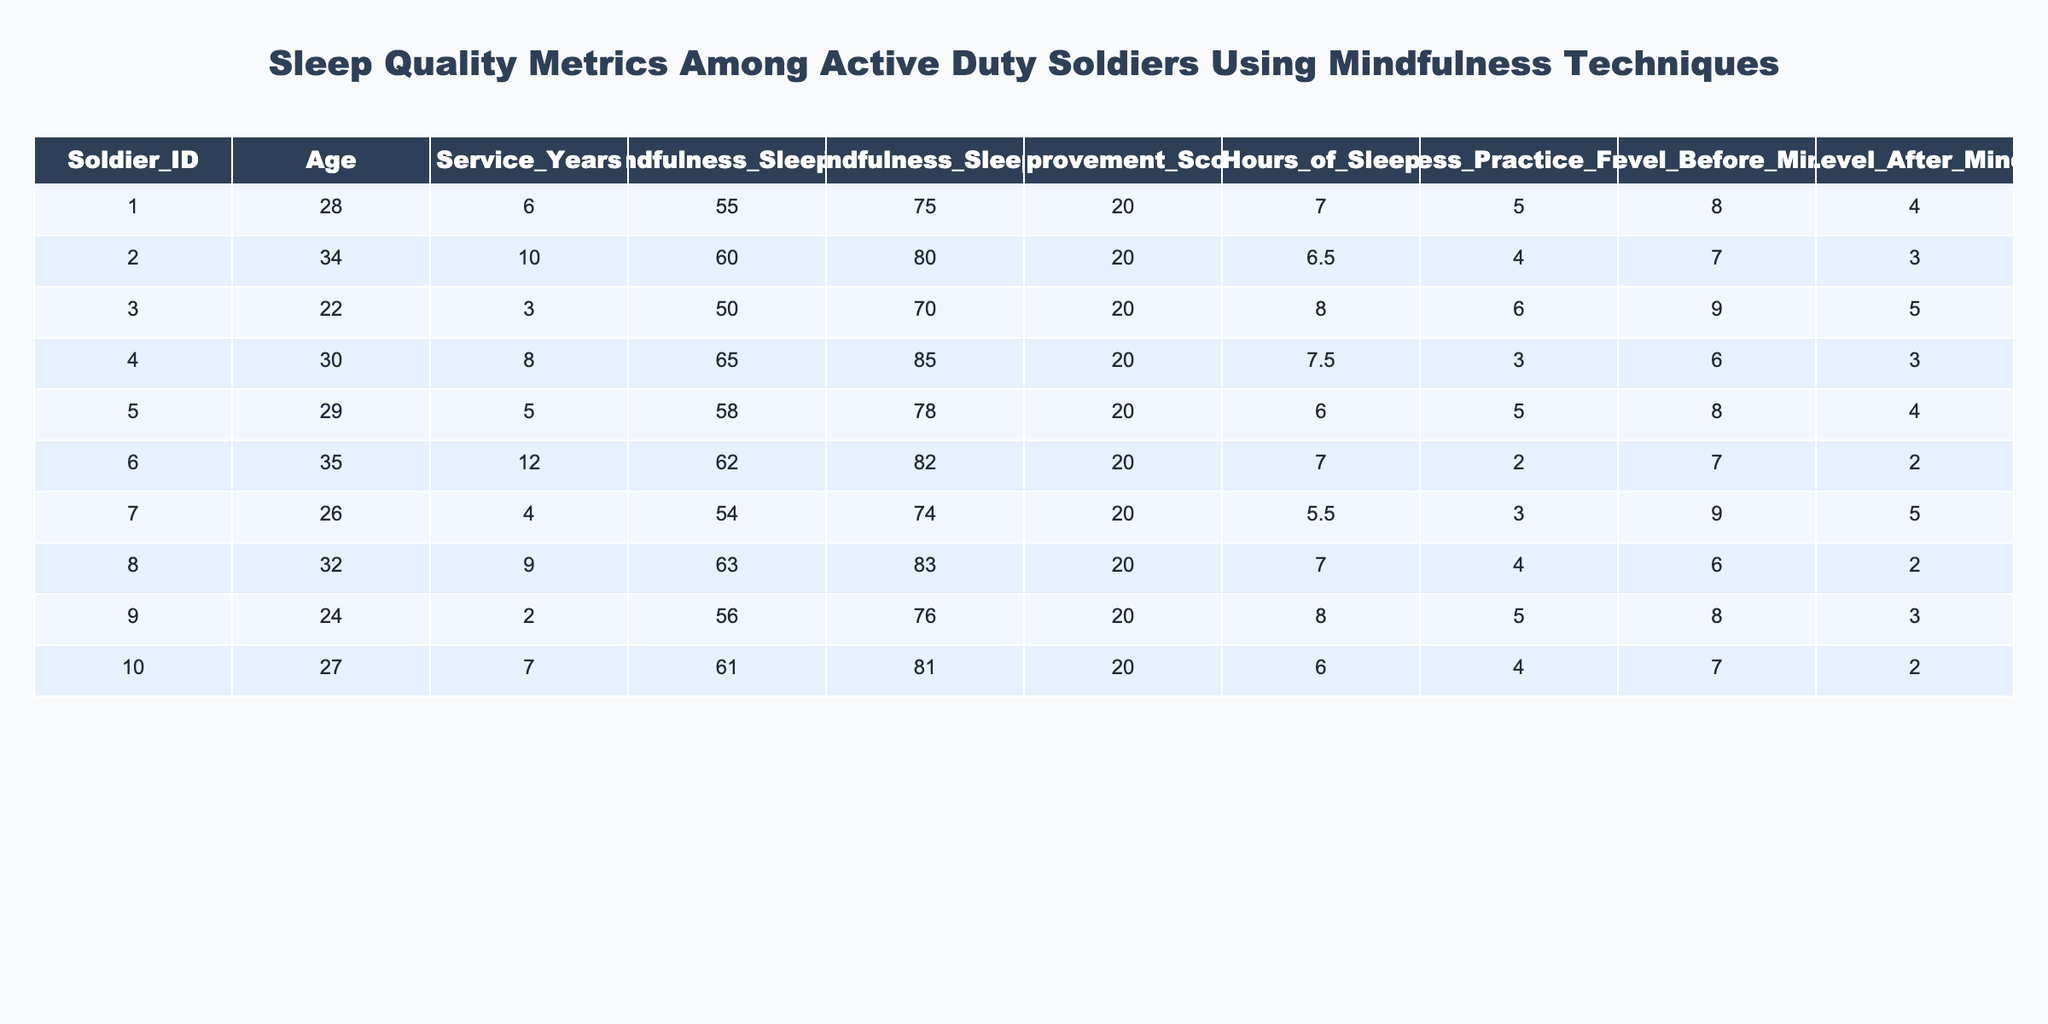What was the improvement score for Soldier ID 003? The improvement score is found directly in the table under the column "Improvement_Score" for Soldier ID 003. It is noted that this score is 20.
Answer: 20 What is the average hours of sleep reported by the soldiers? To calculate the average, sum all values in the "Hours_of_Sleep" column: (7 + 6.5 + 8 + 7.5 + 6 + 7 + 5.5 + 7 + 8 + 6) = 70. Dividing by the number of soldiers (10) gives an average of 70 / 10 = 7.0 hours.
Answer: 7.0 Did all soldiers show an improvement in their sleep scores after mindfulness training? Looking at the "Improvement_Score" for each soldier, all values are positive (20 for all), indicating that every soldier's sleep score improved post-mindfulness.
Answer: Yes What is the stress level change for the soldier with the highest age? Soldier ID 006 is the oldest at age 35. The stress level before mindfulness was 7 and after mindfulness was 2. The change is calculated by subtracting the afterward score from the before score: 7 - 2 = 5, indicating a significant decrease.
Answer: 5 Which soldier had the highest pre-mindfulness sleep score, and what was it? Checking the "Pre_Mindfulness_Sleep_Score" column, Soldier ID 004 has the highest score of 65.
Answer: 65 How many soldiers practiced mindfulness at least 5 times a week? The "Mindfulness_Practice_Frequency" must be counted. Soldiers ID 001, 002, 003, 005, and 009 practiced at least 5 times, totaling 5 soldiers.
Answer: 5 